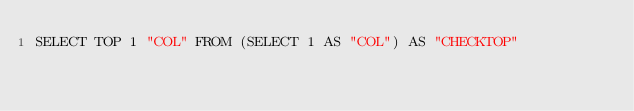Convert code to text. <code><loc_0><loc_0><loc_500><loc_500><_SQL_>SELECT TOP 1 "COL" FROM (SELECT 1 AS "COL") AS "CHECKTOP" 
</code> 